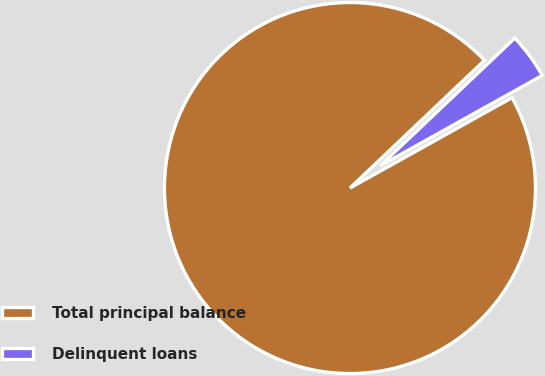<chart> <loc_0><loc_0><loc_500><loc_500><pie_chart><fcel>Total principal balance<fcel>Delinquent loans<nl><fcel>96.01%<fcel>3.99%<nl></chart> 